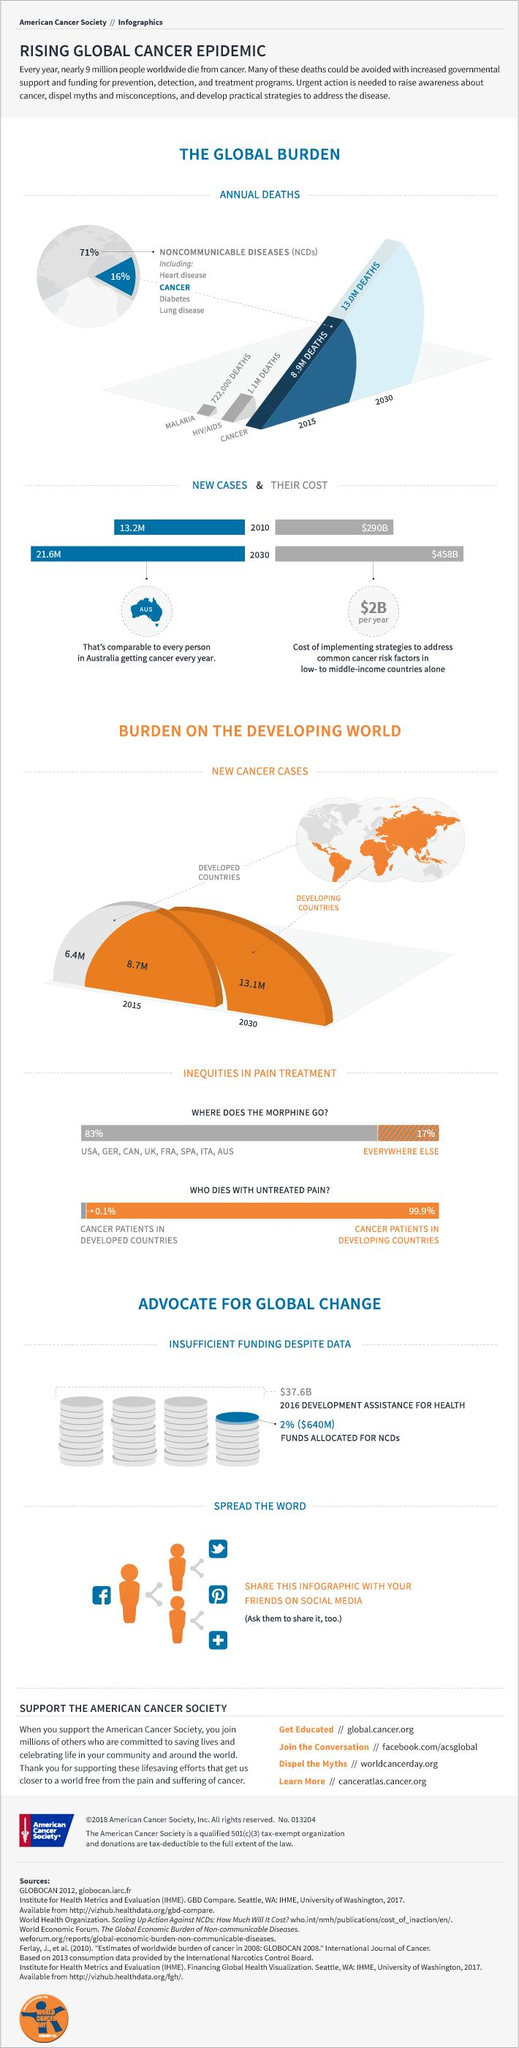Outline some significant characteristics in this image. The number of cancer deaths reported in 2015 was 8.9 million. According to recent studies, only 0.1% of cancer patients in developed countries die due to untreated pain. In 2015, it is estimated that 1.1 million people died due to HIV/AIDS globally. By 2030, it is projected that there will be approximately 13.1 million new cancer cases in developing countries. By the year 2030, it is projected that there will be approximately 13.0 million deaths due to cancer. 